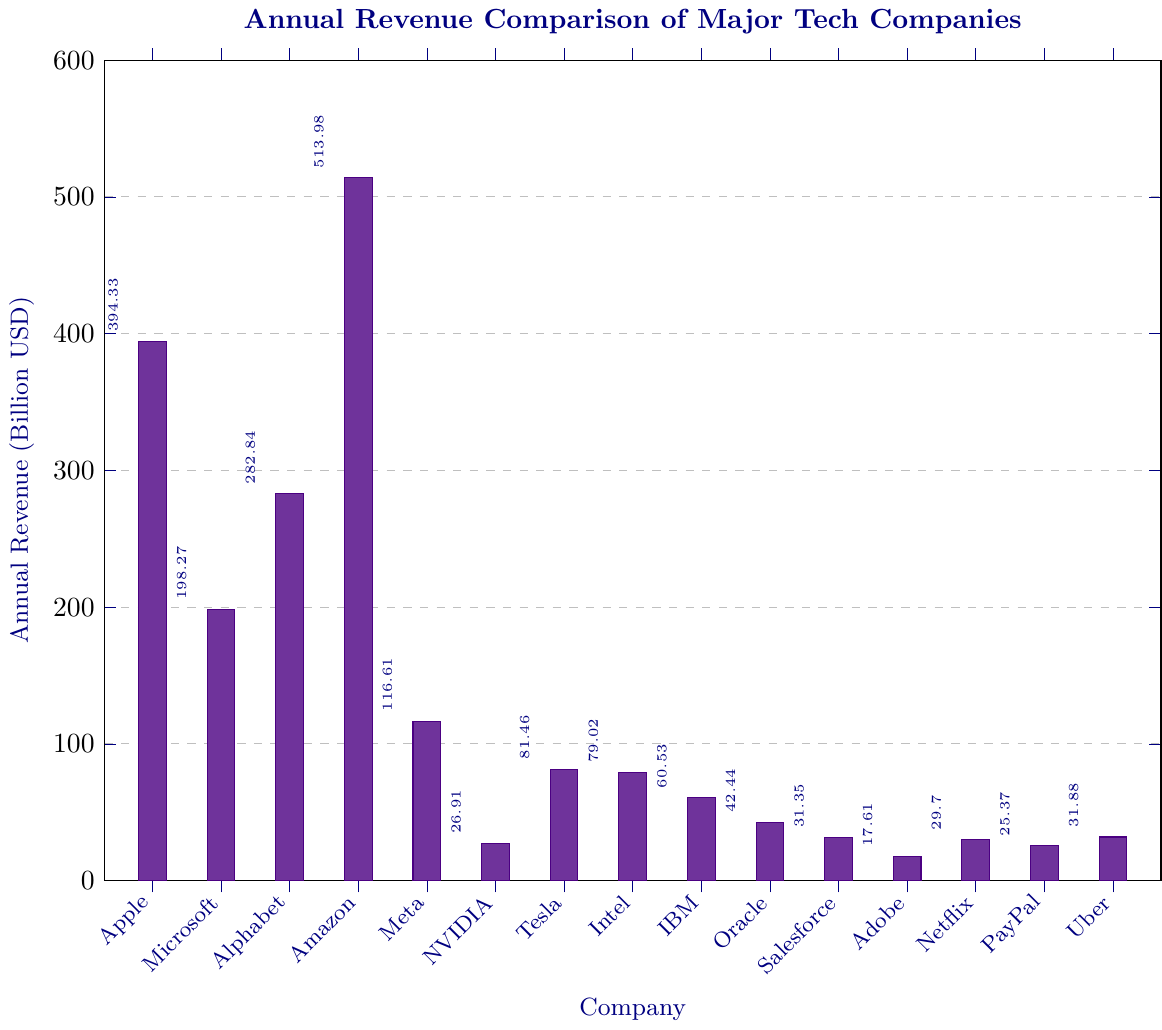Which company has the highest annual revenue? The tallest bar in the bar chart represents Amazon, indicating it has the highest annual revenue.
Answer: Amazon Which two companies have the closest annual revenues? By visually inspecting the heights of the bars, Tesla and Intel have very similar heights, indicating they have closely matching annual revenues.
Answer: Tesla and Intel What is the difference in annual revenue between Apple and Alphabet? Identify the heights of the bars for Apple and Alphabet, then subtract Alphabet's revenue (282.84) from Apple's revenue (394.33). The calculation is 394.33 - 282.84.
Answer: 111.49 billion USD Which company's annual revenue is just less than 200 billion USD? The bar representing Microsoft is slightly below the 200 billion USD mark.
Answer: Microsoft What is the total annual revenue of the five companies with the lowest revenues? Sum the revenues of NVIDIA (26.91), Adobe (17.61), Netflix (29.70), PayPal (25.37), and Salesforce (31.35). The calculation is 26.91 + 17.61 + 29.70 + 25.37 + 31.35.
Answer: 130.94 billion USD How much higher is Amazon's revenue compared to Meta's? Subtract Meta's revenue (116.61) from Amazon's revenue (513.98). The calculation is 513.98 - 116.61.
Answer: 397.37 billion USD What is the average annual revenue of the companies listed? Add all the annual revenues together and then divide by the number of companies (15). The sum is 394.33 + 198.27 + 282.84 + 513.98 + 116.61 + 26.91 + 81.46 + 79.02 + 60.53 + 42.44 + 31.35 + 17.61 + 29.70 + 25.37 + 31.88, which equals 1930.3. Divide by 15.
Answer: 128.687 billion USD Is Adobe's revenue more than PayPal's? Compare the heights of the bars for Adobe and PayPal. Adobe's bar is shorter, meaning Adobe's revenue is less.
Answer: No Which company has a revenue just above 100 billion USD? The bar representing Meta is just above the 100 billion USD mark.
Answer: Meta What is the combined revenue of Intel and IBM? Add the revenues of Intel (79.02) and IBM (60.53). The calculation is 79.02 + 60.53.
Answer: 139.55 billion USD 